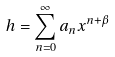<formula> <loc_0><loc_0><loc_500><loc_500>h = \sum _ { n = 0 } ^ { \infty } a _ { n } x ^ { n + \beta }</formula> 